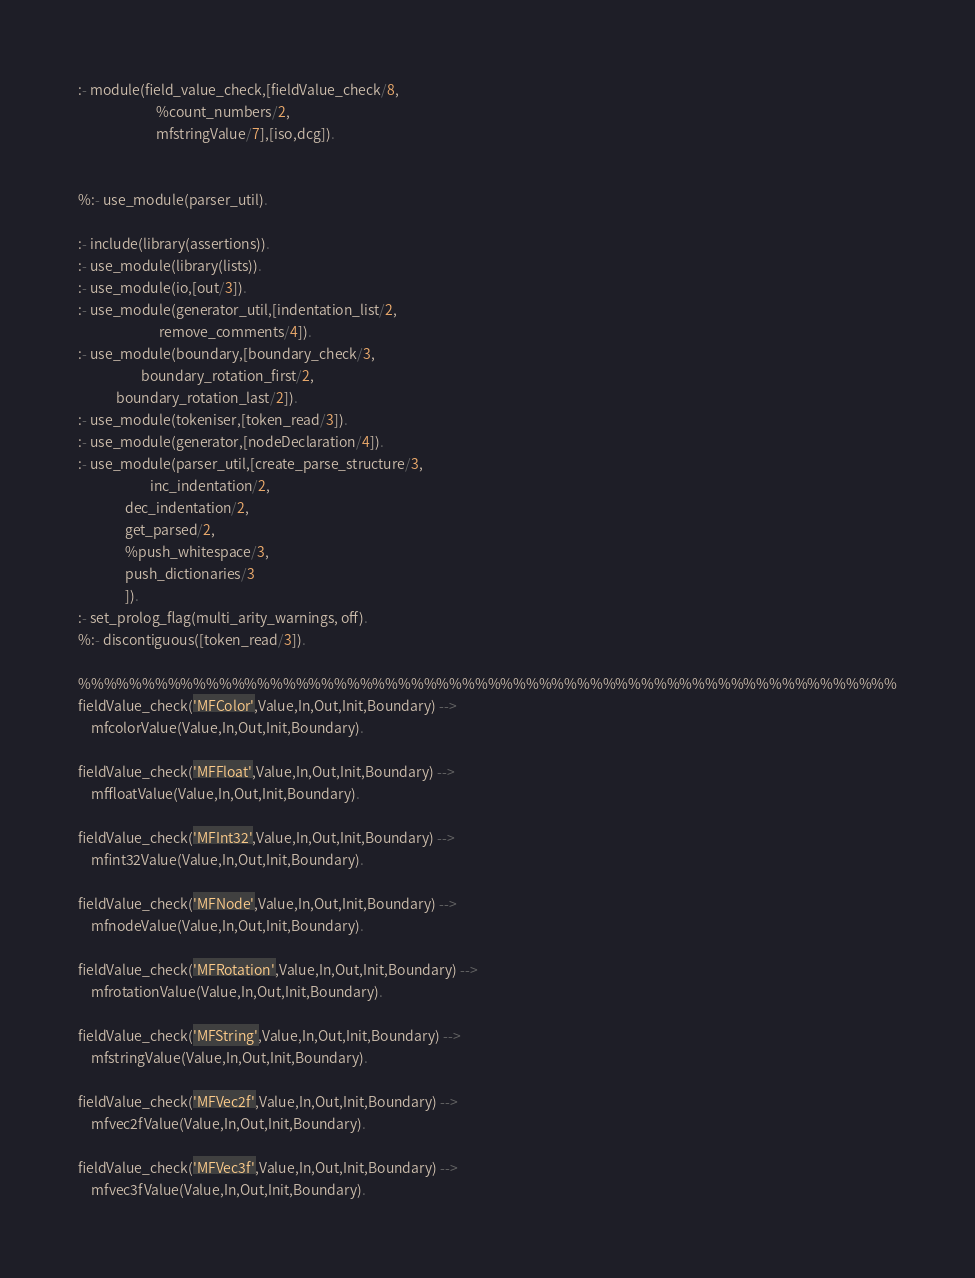Convert code to text. <code><loc_0><loc_0><loc_500><loc_500><_Perl_>:- module(field_value_check,[fieldValue_check/8,
	                     %count_numbers/2,
	                     mfstringValue/7],[iso,dcg]).


%:- use_module(parser_util).

:- include(library(assertions)).
:- use_module(library(lists)).
:- use_module(io,[out/3]).
:- use_module(generator_util,[indentation_list/2,
	                      remove_comments/4]).
:- use_module(boundary,[boundary_check/3,
	                boundary_rotation_first/2,
			boundary_rotation_last/2]).
:- use_module(tokeniser,[token_read/3]).
:- use_module(generator,[nodeDeclaration/4]).
:- use_module(parser_util,[create_parse_structure/3,
	                   inc_indentation/2,
			   dec_indentation/2,
			   get_parsed/2,
			   %push_whitespace/3,
			   push_dictionaries/3
			   ]).
:- set_prolog_flag(multi_arity_warnings, off).
%:- discontiguous([token_read/3]).

%%%%%%%%%%%%%%%%%%%%%%%%%%%%%%%%%%%%%%%%%%%%%%%%%%%%%%%%%%%%%%%%
fieldValue_check('MFColor',Value,In,Out,Init,Boundary) -->
	mfcolorValue(Value,In,Out,Init,Boundary).

fieldValue_check('MFFloat',Value,In,Out,Init,Boundary) -->
	mffloatValue(Value,In,Out,Init,Boundary).

fieldValue_check('MFInt32',Value,In,Out,Init,Boundary) -->
	mfint32Value(Value,In,Out,Init,Boundary).

fieldValue_check('MFNode',Value,In,Out,Init,Boundary) -->
	mfnodeValue(Value,In,Out,Init,Boundary).

fieldValue_check('MFRotation',Value,In,Out,Init,Boundary) -->
	mfrotationValue(Value,In,Out,Init,Boundary).

fieldValue_check('MFString',Value,In,Out,Init,Boundary) -->
	mfstringValue(Value,In,Out,Init,Boundary).

fieldValue_check('MFVec2f',Value,In,Out,Init,Boundary) -->
	mfvec2fValue(Value,In,Out,Init,Boundary).

fieldValue_check('MFVec3f',Value,In,Out,Init,Boundary) -->
	mfvec3fValue(Value,In,Out,Init,Boundary).
</code> 